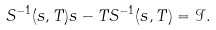<formula> <loc_0><loc_0><loc_500><loc_500>S ^ { - 1 } ( s , T ) s - T S ^ { - 1 } ( s , T ) = \mathcal { I } .</formula> 